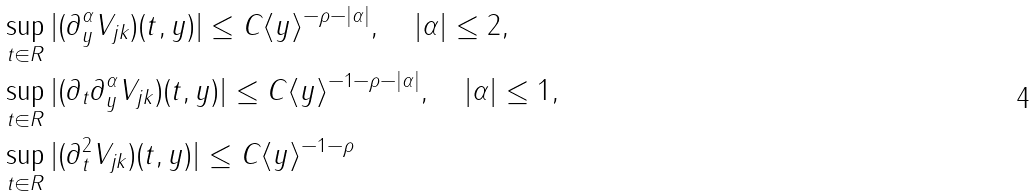<formula> <loc_0><loc_0><loc_500><loc_500>& \sup _ { t \in R } | ( \partial _ { y } ^ { \alpha } V _ { j k } ) ( t , y ) | \leq C \langle y \rangle ^ { - \rho - | \alpha | } , \quad | \alpha | \leq 2 , \\ & \sup _ { t \in R } | ( \partial _ { t } \partial _ { y } ^ { \alpha } V _ { j k } ) ( t , y ) | \leq C \langle y \rangle ^ { - 1 - \rho - | \alpha | } , \quad | \alpha | \leq 1 , \\ & \sup _ { t \in R } | ( \partial _ { t } ^ { 2 } V _ { j k } ) ( t , y ) | \leq C \langle y \rangle ^ { - 1 - \rho }</formula> 